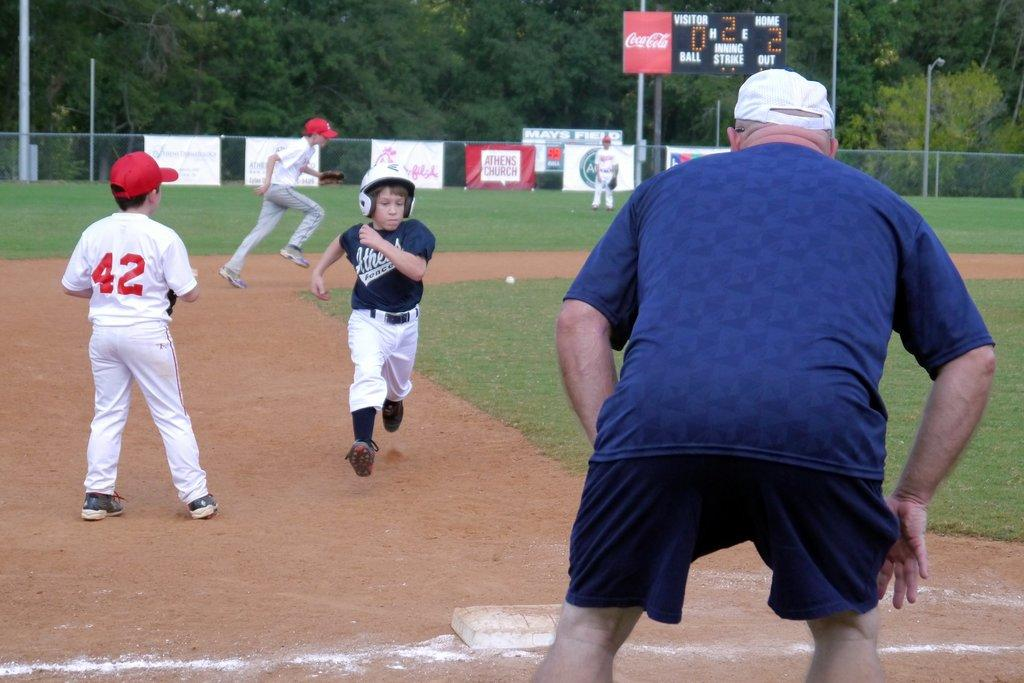Provide a one-sentence caption for the provided image. A boy with the number 42 on the back of his jersey is playing a game of baseball. 